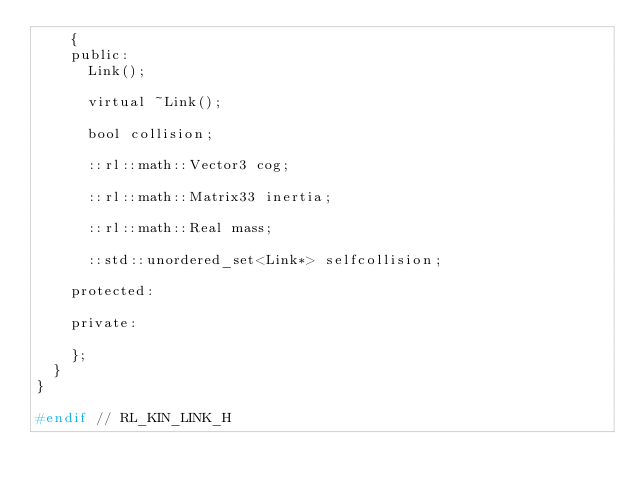Convert code to text. <code><loc_0><loc_0><loc_500><loc_500><_C_>		{
		public:
			Link();
			
			virtual ~Link();
			
			bool collision;
			
			::rl::math::Vector3 cog;
			
			::rl::math::Matrix33 inertia;
			
			::rl::math::Real mass;
			
			::std::unordered_set<Link*> selfcollision;
			
		protected:
			
		private:
			
		};
	}
}

#endif // RL_KIN_LINK_H
</code> 